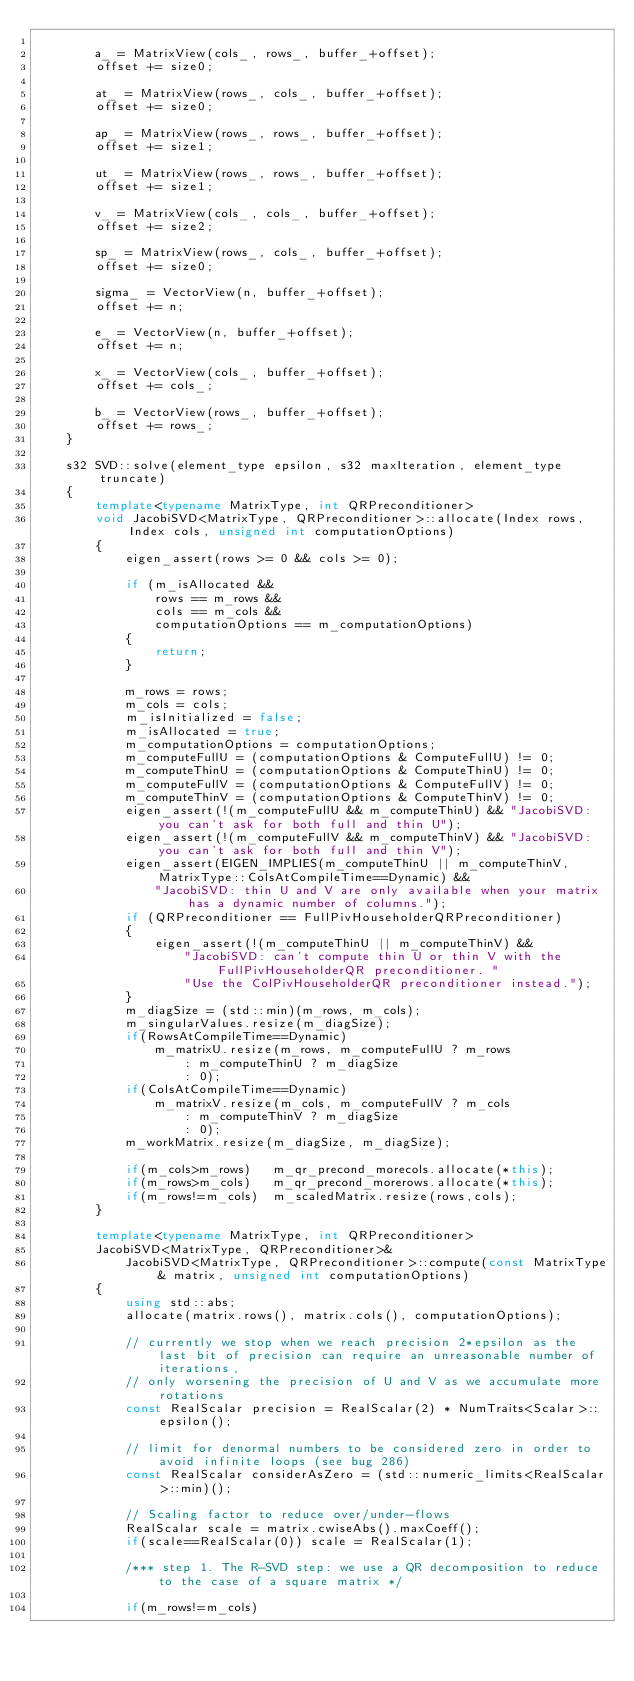<code> <loc_0><loc_0><loc_500><loc_500><_C++_>
        a_ = MatrixView(cols_, rows_, buffer_+offset);
        offset += size0;

        at_ = MatrixView(rows_, cols_, buffer_+offset);
        offset += size0;

        ap_ = MatrixView(rows_, rows_, buffer_+offset);
        offset += size1;

        ut_ = MatrixView(rows_, rows_, buffer_+offset);
        offset += size1;

        v_ = MatrixView(cols_, cols_, buffer_+offset);
        offset += size2;

        sp_ = MatrixView(rows_, cols_, buffer_+offset);
        offset += size0;

        sigma_ = VectorView(n, buffer_+offset);
        offset += n;

        e_ = VectorView(n, buffer_+offset);
        offset += n;

        x_ = VectorView(cols_, buffer_+offset);
        offset += cols_;

        b_ = VectorView(rows_, buffer_+offset);
        offset += rows_;
    }

    s32 SVD::solve(element_type epsilon, s32 maxIteration, element_type truncate)
    {
        template<typename MatrixType, int QRPreconditioner>
        void JacobiSVD<MatrixType, QRPreconditioner>::allocate(Index rows, Index cols, unsigned int computationOptions)
        {
            eigen_assert(rows >= 0 && cols >= 0);

            if (m_isAllocated &&
                rows == m_rows &&
                cols == m_cols &&
                computationOptions == m_computationOptions)
            {
                return;
            }

            m_rows = rows;
            m_cols = cols;
            m_isInitialized = false;
            m_isAllocated = true;
            m_computationOptions = computationOptions;
            m_computeFullU = (computationOptions & ComputeFullU) != 0;
            m_computeThinU = (computationOptions & ComputeThinU) != 0;
            m_computeFullV = (computationOptions & ComputeFullV) != 0;
            m_computeThinV = (computationOptions & ComputeThinV) != 0;
            eigen_assert(!(m_computeFullU && m_computeThinU) && "JacobiSVD: you can't ask for both full and thin U");
            eigen_assert(!(m_computeFullV && m_computeThinV) && "JacobiSVD: you can't ask for both full and thin V");
            eigen_assert(EIGEN_IMPLIES(m_computeThinU || m_computeThinV, MatrixType::ColsAtCompileTime==Dynamic) &&
                "JacobiSVD: thin U and V are only available when your matrix has a dynamic number of columns.");
            if (QRPreconditioner == FullPivHouseholderQRPreconditioner)
            {
                eigen_assert(!(m_computeThinU || m_computeThinV) &&
                    "JacobiSVD: can't compute thin U or thin V with the FullPivHouseholderQR preconditioner. "
                    "Use the ColPivHouseholderQR preconditioner instead.");
            }
            m_diagSize = (std::min)(m_rows, m_cols);
            m_singularValues.resize(m_diagSize);
            if(RowsAtCompileTime==Dynamic)
                m_matrixU.resize(m_rows, m_computeFullU ? m_rows
                    : m_computeThinU ? m_diagSize
                    : 0);
            if(ColsAtCompileTime==Dynamic)
                m_matrixV.resize(m_cols, m_computeFullV ? m_cols
                    : m_computeThinV ? m_diagSize
                    : 0);
            m_workMatrix.resize(m_diagSize, m_diagSize);

            if(m_cols>m_rows)   m_qr_precond_morecols.allocate(*this);
            if(m_rows>m_cols)   m_qr_precond_morerows.allocate(*this);
            if(m_rows!=m_cols)  m_scaledMatrix.resize(rows,cols);
        }

        template<typename MatrixType, int QRPreconditioner>
        JacobiSVD<MatrixType, QRPreconditioner>&
            JacobiSVD<MatrixType, QRPreconditioner>::compute(const MatrixType& matrix, unsigned int computationOptions)
        {
            using std::abs;
            allocate(matrix.rows(), matrix.cols(), computationOptions);

            // currently we stop when we reach precision 2*epsilon as the last bit of precision can require an unreasonable number of iterations,
            // only worsening the precision of U and V as we accumulate more rotations
            const RealScalar precision = RealScalar(2) * NumTraits<Scalar>::epsilon();

            // limit for denormal numbers to be considered zero in order to avoid infinite loops (see bug 286)
            const RealScalar considerAsZero = (std::numeric_limits<RealScalar>::min)();

            // Scaling factor to reduce over/under-flows
            RealScalar scale = matrix.cwiseAbs().maxCoeff();
            if(scale==RealScalar(0)) scale = RealScalar(1);

            /*** step 1. The R-SVD step: we use a QR decomposition to reduce to the case of a square matrix */

            if(m_rows!=m_cols)</code> 